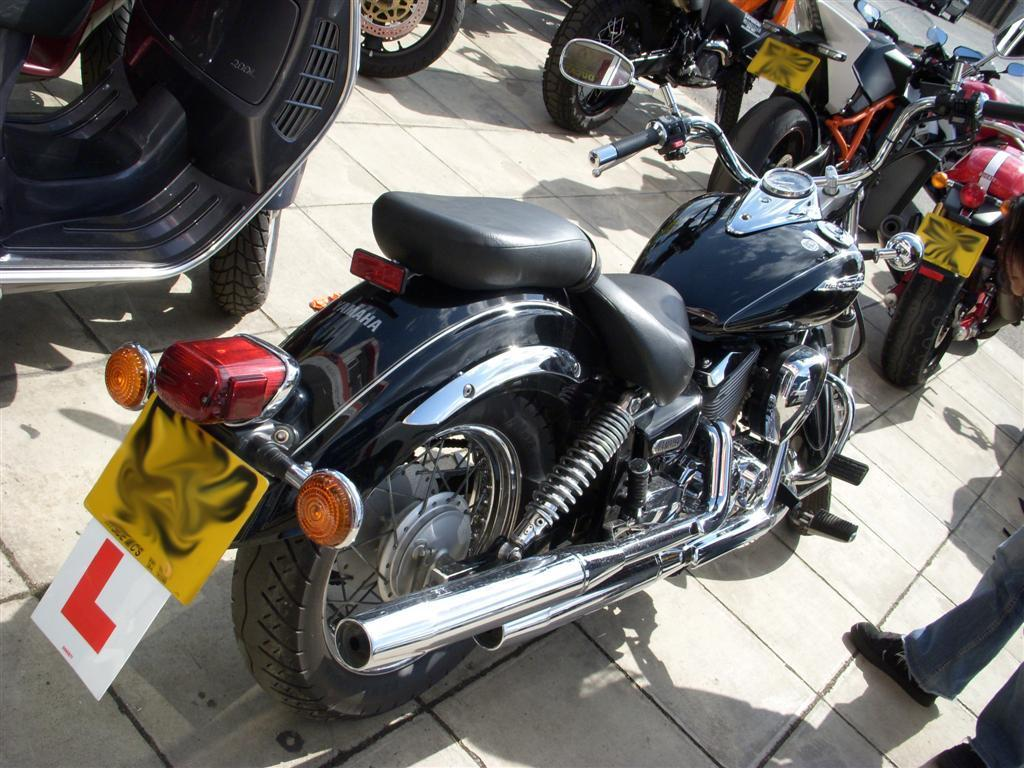What type of vehicles are present in the image? There are various bikes in the image. Where might the image have been taken? The image may have been taken in a parking lot. Can you describe the people in the image? The legs of persons are visible on the right side of the image. What is visible in the top right corner of the image? There is a road visible at the top right of the image. What type of parcel is being delivered by the queen in the image? There is no queen or parcel present in the image. What type of destruction can be seen in the image? There is no destruction present in the image; it features bikes and a parking lot. 